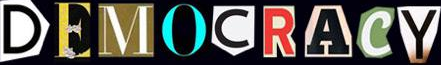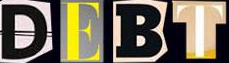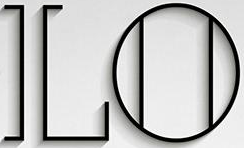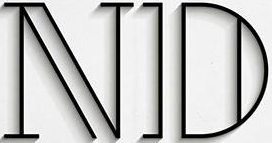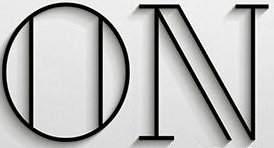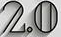Identify the words shown in these images in order, separated by a semicolon. DEMOCRACY; DEBT; LO; ND; ON; 2.0 